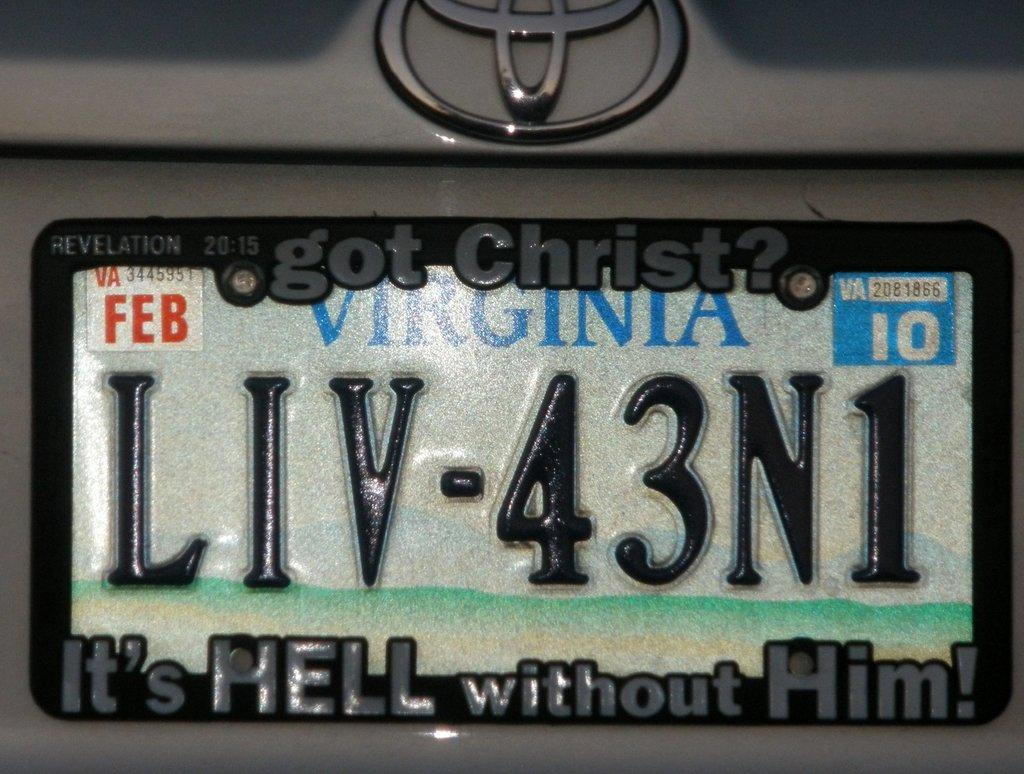<image>
Give a short and clear explanation of the subsequent image. State of Virginia licence plate, LIV-43N1 with a frame that says "Got Christ? It's He'll without Him!". 